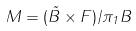<formula> <loc_0><loc_0><loc_500><loc_500>M = ( \tilde { B } \times F ) / \pi _ { 1 } B</formula> 